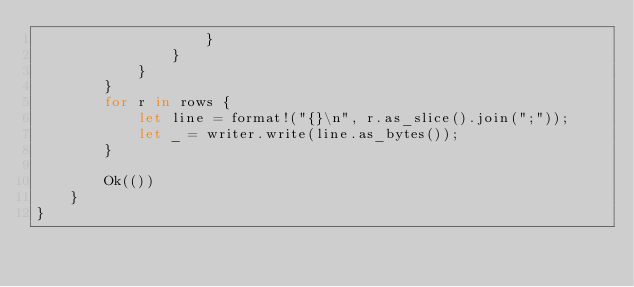Convert code to text. <code><loc_0><loc_0><loc_500><loc_500><_Rust_>                    }
                }
            }
        }
        for r in rows {
            let line = format!("{}\n", r.as_slice().join(";"));
            let _ = writer.write(line.as_bytes());
        }

        Ok(())
    }
}
</code> 